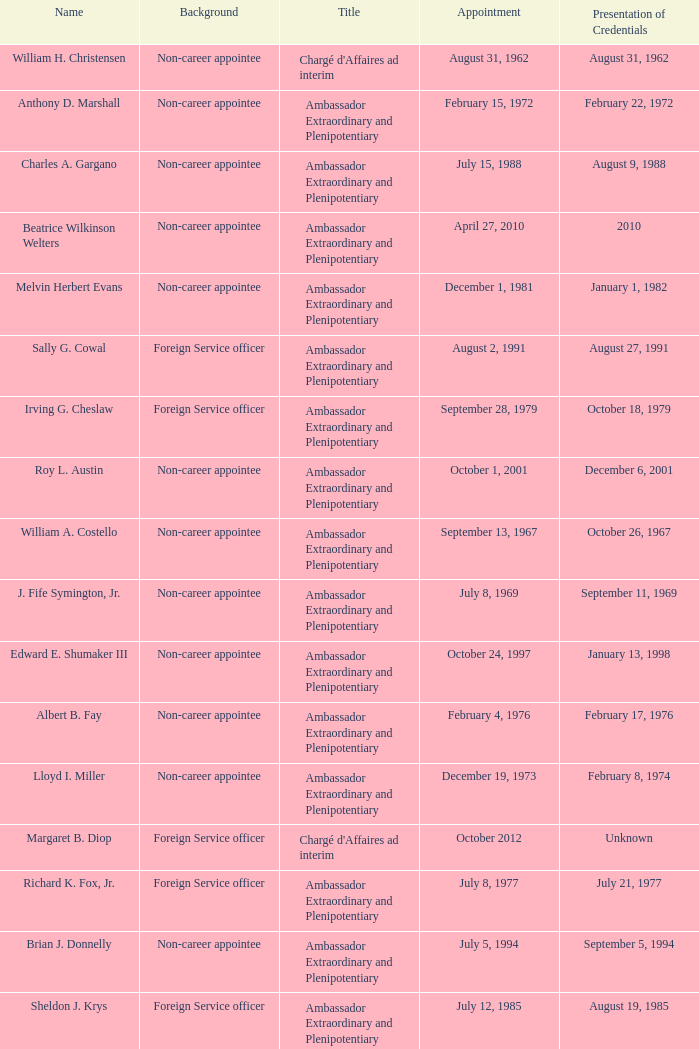When was william a. costello designated? September 13, 1967. 